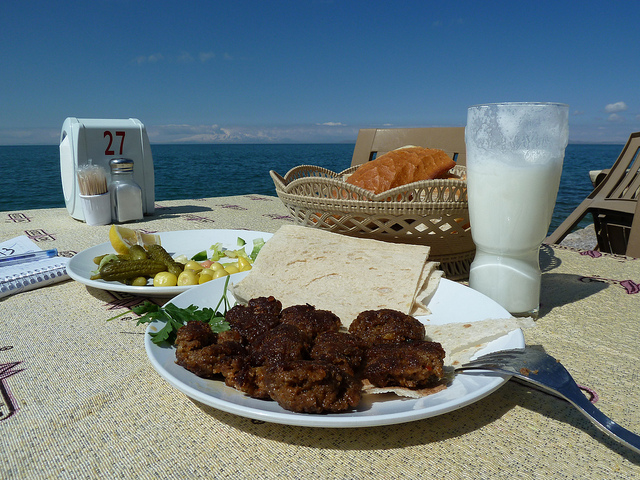Imagine a story where this dining scene plays a crucial role. In a quaint coastal town, a renowned chef decided to take a well-deserved break from the bustling city life. She opted for a small, hidden gem of a café by the ocean where she could savor a simple yet flavorful meal. With every bite, memories of her grandmother's recipes flooded her mind, and an idea for her new restaurant theme began to crystallize – a fusion of fresh, local ingredients with traditional family recipes, creating a unique culinary experience that connected generations. Can you create a poem inspired by this image? Upon the table by the sea,
A feast is laid out splendidly.
With bread so warm and milk so pure,
A tranquil meal, a calm so sure.
The waves they crash, the seagulls fly,
Beneath the vast and open sky.
Here one dines, with heart at rest,
Nature’s view, forever blessed. 